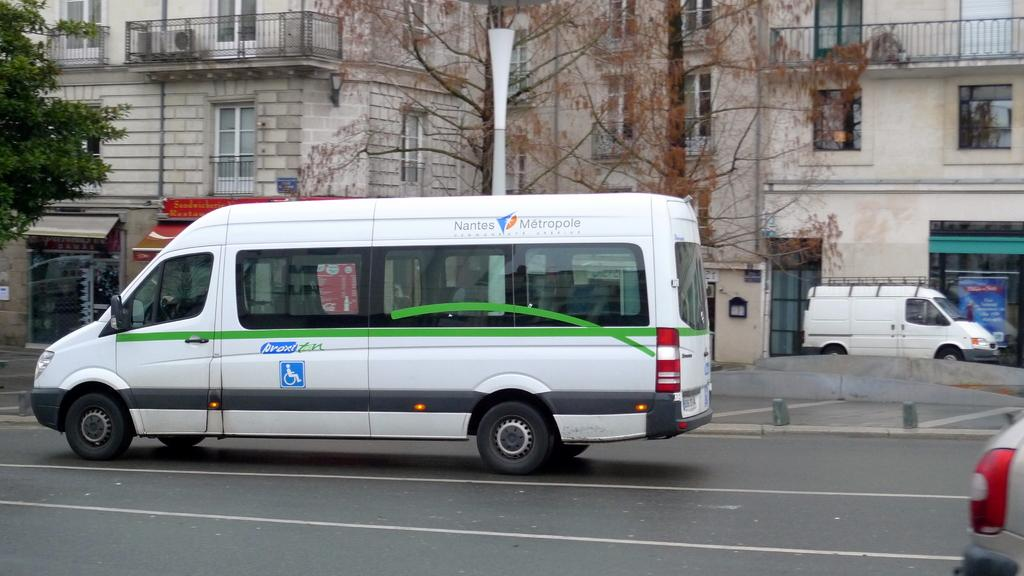What color are the vehicles on the road in the image? The vehicles on the road are white. What can be seen on either side of the road? Trees and houses are visible on either side of the road. What type of bun is being used to hold the order in the image? There is no bun or order present in the image; it features white vehicles on the road with trees and houses on either side. 